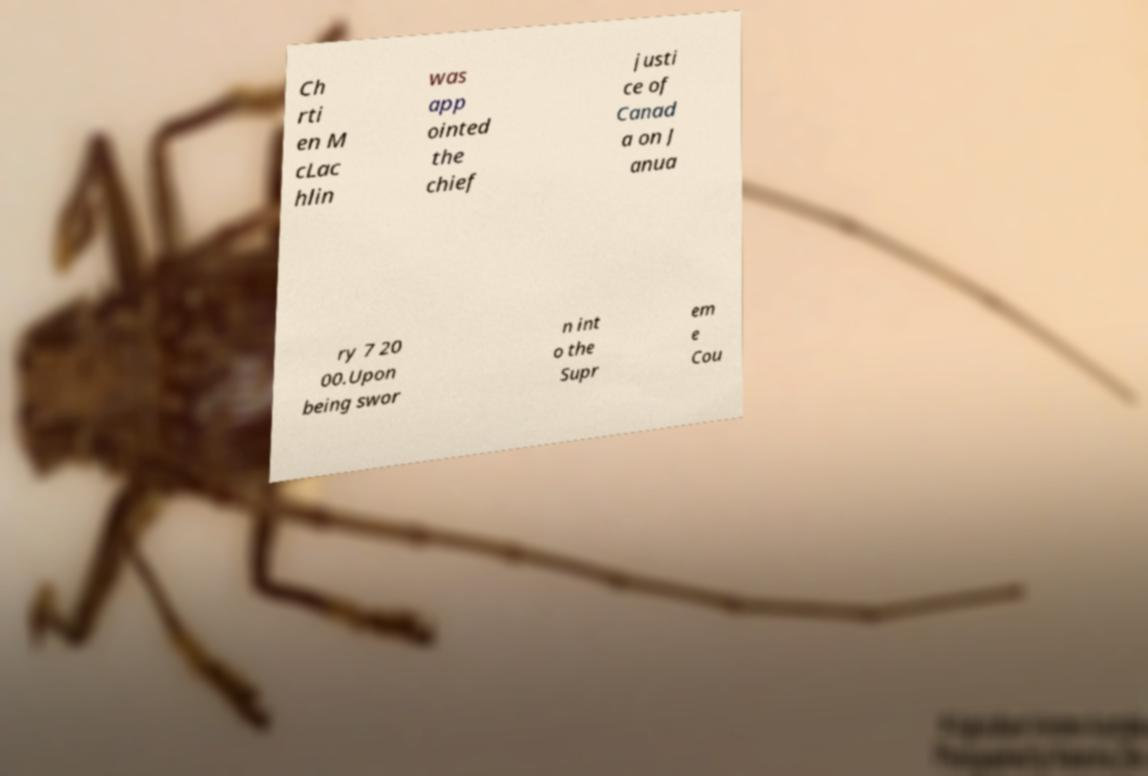Could you assist in decoding the text presented in this image and type it out clearly? Ch rti en M cLac hlin was app ointed the chief justi ce of Canad a on J anua ry 7 20 00.Upon being swor n int o the Supr em e Cou 